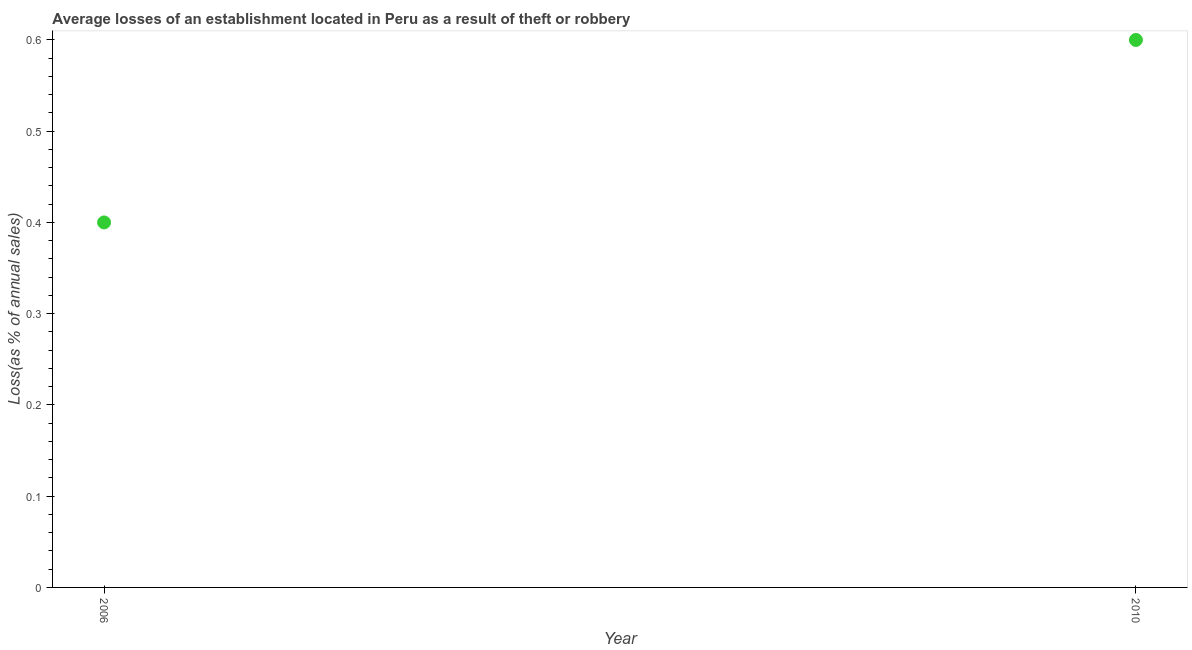Across all years, what is the maximum losses due to theft?
Give a very brief answer. 0.6. In which year was the losses due to theft maximum?
Your answer should be very brief. 2010. In which year was the losses due to theft minimum?
Ensure brevity in your answer.  2006. What is the difference between the losses due to theft in 2006 and 2010?
Give a very brief answer. -0.2. What is the average losses due to theft per year?
Provide a short and direct response. 0.5. In how many years, is the losses due to theft greater than 0.52 %?
Your answer should be compact. 1. What is the ratio of the losses due to theft in 2006 to that in 2010?
Offer a very short reply. 0.67. Is the losses due to theft in 2006 less than that in 2010?
Your response must be concise. Yes. In how many years, is the losses due to theft greater than the average losses due to theft taken over all years?
Keep it short and to the point. 1. How many years are there in the graph?
Provide a short and direct response. 2. Does the graph contain grids?
Offer a terse response. No. What is the title of the graph?
Keep it short and to the point. Average losses of an establishment located in Peru as a result of theft or robbery. What is the label or title of the Y-axis?
Your answer should be very brief. Loss(as % of annual sales). What is the Loss(as % of annual sales) in 2010?
Your response must be concise. 0.6. What is the difference between the Loss(as % of annual sales) in 2006 and 2010?
Keep it short and to the point. -0.2. What is the ratio of the Loss(as % of annual sales) in 2006 to that in 2010?
Offer a terse response. 0.67. 